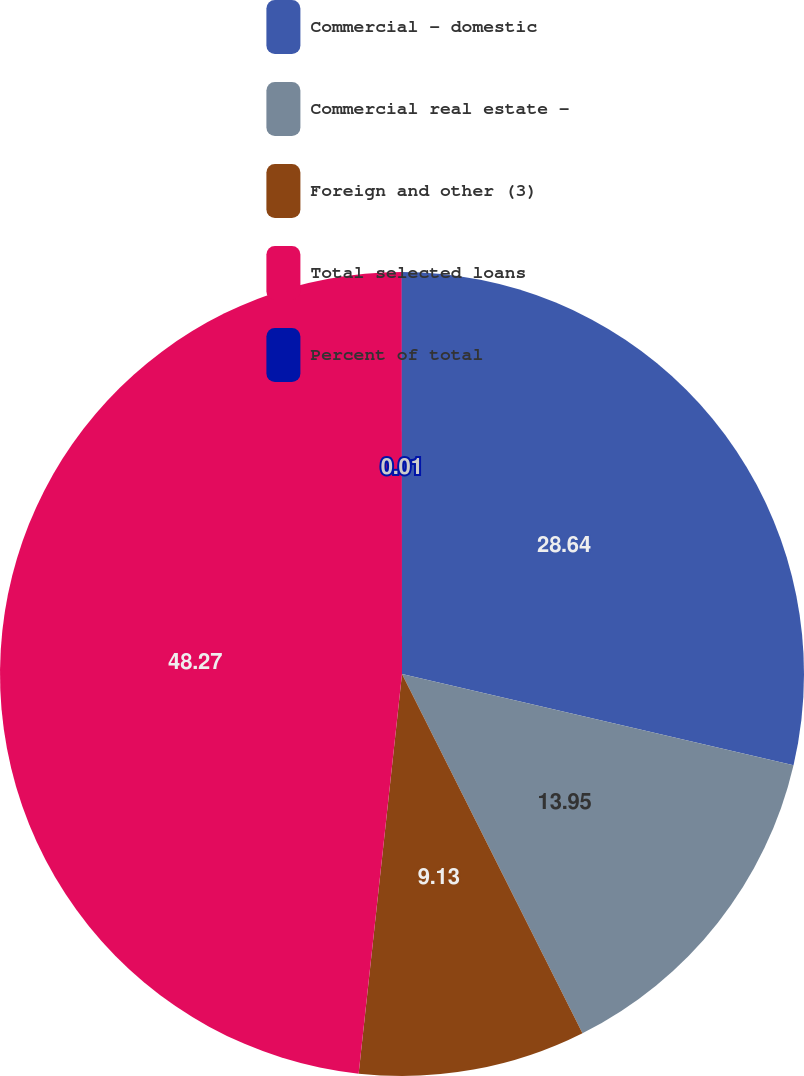Convert chart. <chart><loc_0><loc_0><loc_500><loc_500><pie_chart><fcel>Commercial - domestic<fcel>Commercial real estate -<fcel>Foreign and other (3)<fcel>Total selected loans<fcel>Percent of total<nl><fcel>28.64%<fcel>13.95%<fcel>9.13%<fcel>48.27%<fcel>0.01%<nl></chart> 